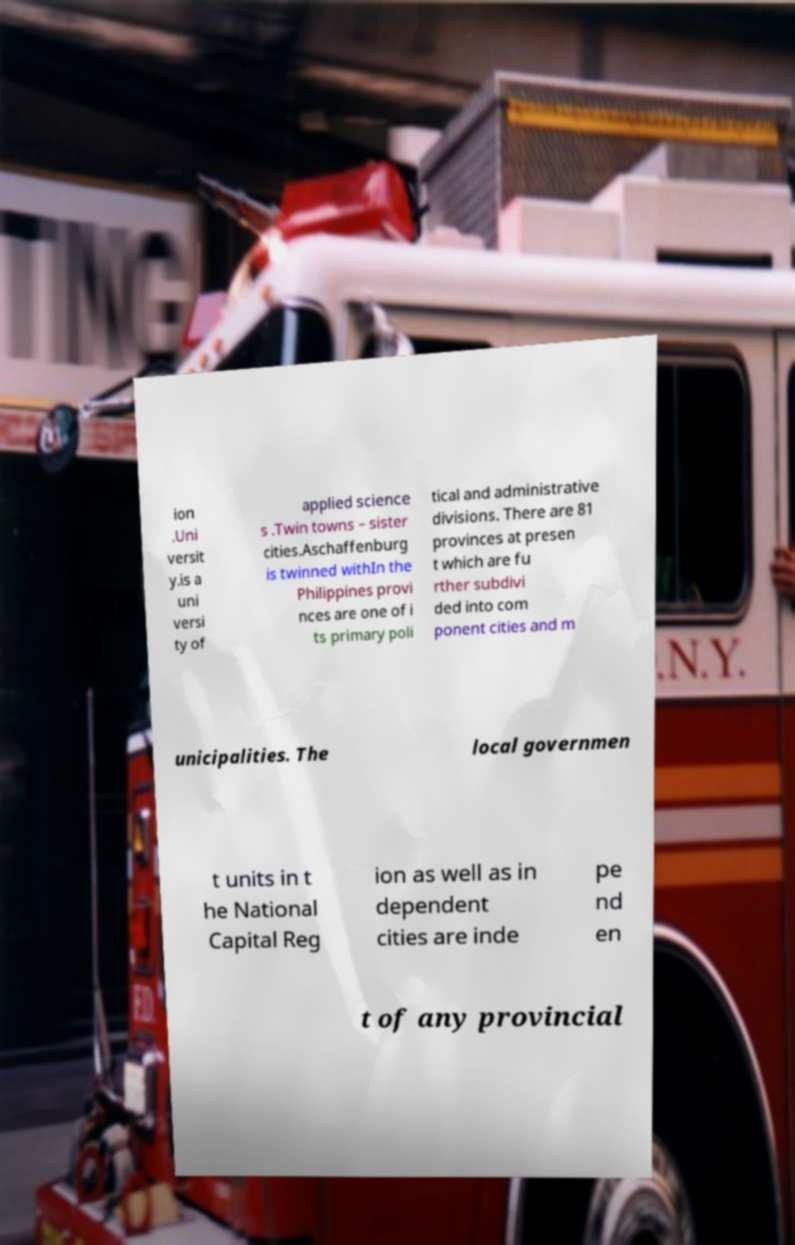Please read and relay the text visible in this image. What does it say? ion .Uni versit y.is a uni versi ty of applied science s .Twin towns – sister cities.Aschaffenburg is twinned withIn the Philippines provi nces are one of i ts primary poli tical and administrative divisions. There are 81 provinces at presen t which are fu rther subdivi ded into com ponent cities and m unicipalities. The local governmen t units in t he National Capital Reg ion as well as in dependent cities are inde pe nd en t of any provincial 